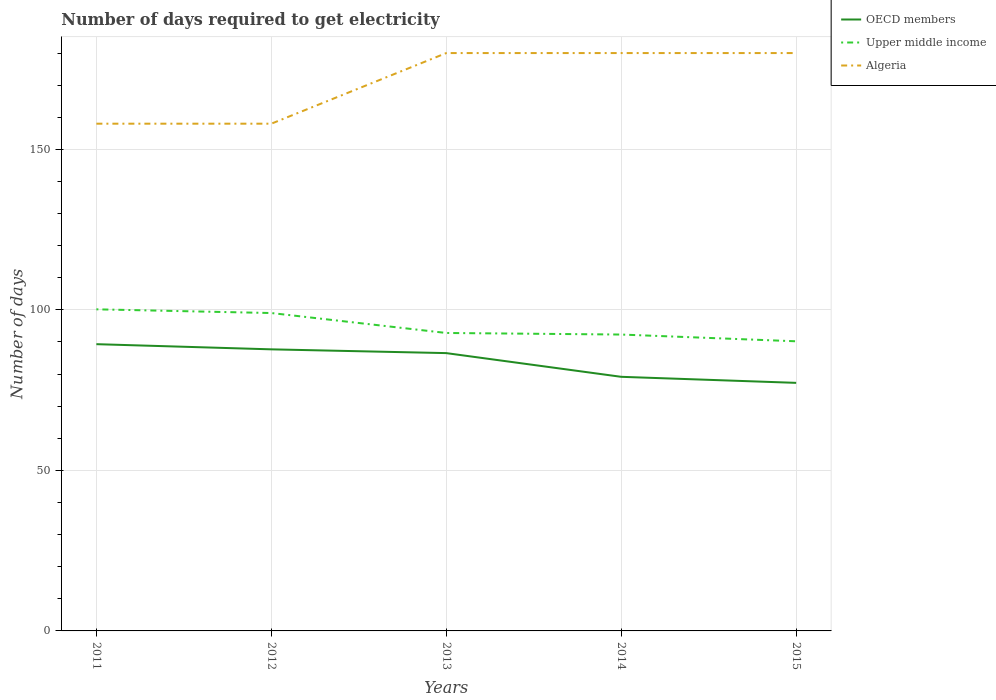How many different coloured lines are there?
Your answer should be compact. 3. Does the line corresponding to Upper middle income intersect with the line corresponding to OECD members?
Give a very brief answer. No. Is the number of lines equal to the number of legend labels?
Give a very brief answer. Yes. Across all years, what is the maximum number of days required to get electricity in in Algeria?
Your answer should be compact. 158. What is the total number of days required to get electricity in in OECD members in the graph?
Offer a terse response. 7.38. What is the difference between the highest and the second highest number of days required to get electricity in in OECD members?
Provide a succinct answer. 12.05. How many lines are there?
Your answer should be compact. 3. Where does the legend appear in the graph?
Provide a succinct answer. Top right. How many legend labels are there?
Your answer should be very brief. 3. What is the title of the graph?
Keep it short and to the point. Number of days required to get electricity. Does "Sub-Saharan Africa (developing only)" appear as one of the legend labels in the graph?
Keep it short and to the point. No. What is the label or title of the Y-axis?
Ensure brevity in your answer.  Number of days. What is the Number of days in OECD members in 2011?
Keep it short and to the point. 89.32. What is the Number of days in Upper middle income in 2011?
Your answer should be very brief. 100.18. What is the Number of days in Algeria in 2011?
Your answer should be very brief. 158. What is the Number of days of OECD members in 2012?
Your answer should be very brief. 87.71. What is the Number of days in Upper middle income in 2012?
Your answer should be very brief. 99.02. What is the Number of days of Algeria in 2012?
Give a very brief answer. 158. What is the Number of days of OECD members in 2013?
Ensure brevity in your answer.  86.54. What is the Number of days of Upper middle income in 2013?
Give a very brief answer. 92.81. What is the Number of days of Algeria in 2013?
Provide a succinct answer. 180. What is the Number of days of OECD members in 2014?
Provide a succinct answer. 79.15. What is the Number of days in Upper middle income in 2014?
Make the answer very short. 92.32. What is the Number of days in Algeria in 2014?
Make the answer very short. 180. What is the Number of days of OECD members in 2015?
Offer a terse response. 77.27. What is the Number of days of Upper middle income in 2015?
Your answer should be compact. 90.22. What is the Number of days in Algeria in 2015?
Make the answer very short. 180. Across all years, what is the maximum Number of days of OECD members?
Your response must be concise. 89.32. Across all years, what is the maximum Number of days in Upper middle income?
Ensure brevity in your answer.  100.18. Across all years, what is the maximum Number of days in Algeria?
Give a very brief answer. 180. Across all years, what is the minimum Number of days in OECD members?
Provide a succinct answer. 77.27. Across all years, what is the minimum Number of days in Upper middle income?
Your answer should be compact. 90.22. Across all years, what is the minimum Number of days in Algeria?
Your answer should be very brief. 158. What is the total Number of days in OECD members in the graph?
Offer a terse response. 419.99. What is the total Number of days of Upper middle income in the graph?
Offer a very short reply. 474.55. What is the total Number of days in Algeria in the graph?
Provide a short and direct response. 856. What is the difference between the Number of days of OECD members in 2011 and that in 2012?
Ensure brevity in your answer.  1.61. What is the difference between the Number of days of Upper middle income in 2011 and that in 2012?
Your answer should be compact. 1.16. What is the difference between the Number of days of Algeria in 2011 and that in 2012?
Give a very brief answer. 0. What is the difference between the Number of days in OECD members in 2011 and that in 2013?
Make the answer very short. 2.79. What is the difference between the Number of days of Upper middle income in 2011 and that in 2013?
Your answer should be compact. 7.37. What is the difference between the Number of days of Algeria in 2011 and that in 2013?
Provide a short and direct response. -22. What is the difference between the Number of days in OECD members in 2011 and that in 2014?
Provide a short and direct response. 10.17. What is the difference between the Number of days in Upper middle income in 2011 and that in 2014?
Offer a very short reply. 7.86. What is the difference between the Number of days in Algeria in 2011 and that in 2014?
Ensure brevity in your answer.  -22. What is the difference between the Number of days of OECD members in 2011 and that in 2015?
Provide a short and direct response. 12.05. What is the difference between the Number of days of Upper middle income in 2011 and that in 2015?
Your answer should be very brief. 9.96. What is the difference between the Number of days in OECD members in 2012 and that in 2013?
Offer a very short reply. 1.17. What is the difference between the Number of days of Upper middle income in 2012 and that in 2013?
Offer a terse response. 6.21. What is the difference between the Number of days in OECD members in 2012 and that in 2014?
Ensure brevity in your answer.  8.56. What is the difference between the Number of days of Upper middle income in 2012 and that in 2014?
Offer a terse response. 6.7. What is the difference between the Number of days in OECD members in 2012 and that in 2015?
Offer a very short reply. 10.44. What is the difference between the Number of days of Upper middle income in 2012 and that in 2015?
Make the answer very short. 8.8. What is the difference between the Number of days in OECD members in 2013 and that in 2014?
Provide a short and direct response. 7.38. What is the difference between the Number of days in Upper middle income in 2013 and that in 2014?
Keep it short and to the point. 0.49. What is the difference between the Number of days in Algeria in 2013 and that in 2014?
Keep it short and to the point. 0. What is the difference between the Number of days of OECD members in 2013 and that in 2015?
Provide a short and direct response. 9.26. What is the difference between the Number of days in Upper middle income in 2013 and that in 2015?
Ensure brevity in your answer.  2.59. What is the difference between the Number of days of OECD members in 2014 and that in 2015?
Keep it short and to the point. 1.88. What is the difference between the Number of days in Upper middle income in 2014 and that in 2015?
Keep it short and to the point. 2.1. What is the difference between the Number of days in Algeria in 2014 and that in 2015?
Give a very brief answer. 0. What is the difference between the Number of days in OECD members in 2011 and the Number of days in Upper middle income in 2012?
Make the answer very short. -9.7. What is the difference between the Number of days in OECD members in 2011 and the Number of days in Algeria in 2012?
Give a very brief answer. -68.68. What is the difference between the Number of days in Upper middle income in 2011 and the Number of days in Algeria in 2012?
Offer a very short reply. -57.82. What is the difference between the Number of days of OECD members in 2011 and the Number of days of Upper middle income in 2013?
Give a very brief answer. -3.49. What is the difference between the Number of days in OECD members in 2011 and the Number of days in Algeria in 2013?
Your answer should be very brief. -90.68. What is the difference between the Number of days in Upper middle income in 2011 and the Number of days in Algeria in 2013?
Provide a short and direct response. -79.82. What is the difference between the Number of days in OECD members in 2011 and the Number of days in Upper middle income in 2014?
Your response must be concise. -3. What is the difference between the Number of days in OECD members in 2011 and the Number of days in Algeria in 2014?
Provide a short and direct response. -90.68. What is the difference between the Number of days in Upper middle income in 2011 and the Number of days in Algeria in 2014?
Offer a very short reply. -79.82. What is the difference between the Number of days of OECD members in 2011 and the Number of days of Upper middle income in 2015?
Offer a terse response. -0.9. What is the difference between the Number of days of OECD members in 2011 and the Number of days of Algeria in 2015?
Your answer should be compact. -90.68. What is the difference between the Number of days of Upper middle income in 2011 and the Number of days of Algeria in 2015?
Keep it short and to the point. -79.82. What is the difference between the Number of days in OECD members in 2012 and the Number of days in Upper middle income in 2013?
Your answer should be compact. -5.1. What is the difference between the Number of days of OECD members in 2012 and the Number of days of Algeria in 2013?
Make the answer very short. -92.29. What is the difference between the Number of days in Upper middle income in 2012 and the Number of days in Algeria in 2013?
Provide a succinct answer. -80.98. What is the difference between the Number of days in OECD members in 2012 and the Number of days in Upper middle income in 2014?
Provide a short and direct response. -4.61. What is the difference between the Number of days of OECD members in 2012 and the Number of days of Algeria in 2014?
Give a very brief answer. -92.29. What is the difference between the Number of days in Upper middle income in 2012 and the Number of days in Algeria in 2014?
Your answer should be compact. -80.98. What is the difference between the Number of days of OECD members in 2012 and the Number of days of Upper middle income in 2015?
Ensure brevity in your answer.  -2.51. What is the difference between the Number of days in OECD members in 2012 and the Number of days in Algeria in 2015?
Keep it short and to the point. -92.29. What is the difference between the Number of days in Upper middle income in 2012 and the Number of days in Algeria in 2015?
Keep it short and to the point. -80.98. What is the difference between the Number of days in OECD members in 2013 and the Number of days in Upper middle income in 2014?
Give a very brief answer. -5.79. What is the difference between the Number of days of OECD members in 2013 and the Number of days of Algeria in 2014?
Make the answer very short. -93.46. What is the difference between the Number of days of Upper middle income in 2013 and the Number of days of Algeria in 2014?
Provide a short and direct response. -87.19. What is the difference between the Number of days in OECD members in 2013 and the Number of days in Upper middle income in 2015?
Your response must be concise. -3.68. What is the difference between the Number of days of OECD members in 2013 and the Number of days of Algeria in 2015?
Ensure brevity in your answer.  -93.46. What is the difference between the Number of days in Upper middle income in 2013 and the Number of days in Algeria in 2015?
Your answer should be compact. -87.19. What is the difference between the Number of days of OECD members in 2014 and the Number of days of Upper middle income in 2015?
Provide a short and direct response. -11.07. What is the difference between the Number of days in OECD members in 2014 and the Number of days in Algeria in 2015?
Your answer should be very brief. -100.85. What is the difference between the Number of days of Upper middle income in 2014 and the Number of days of Algeria in 2015?
Your answer should be compact. -87.68. What is the average Number of days of OECD members per year?
Your answer should be compact. 84. What is the average Number of days in Upper middle income per year?
Your answer should be compact. 94.91. What is the average Number of days of Algeria per year?
Give a very brief answer. 171.2. In the year 2011, what is the difference between the Number of days in OECD members and Number of days in Upper middle income?
Provide a succinct answer. -10.86. In the year 2011, what is the difference between the Number of days in OECD members and Number of days in Algeria?
Provide a succinct answer. -68.68. In the year 2011, what is the difference between the Number of days in Upper middle income and Number of days in Algeria?
Make the answer very short. -57.82. In the year 2012, what is the difference between the Number of days of OECD members and Number of days of Upper middle income?
Keep it short and to the point. -11.31. In the year 2012, what is the difference between the Number of days of OECD members and Number of days of Algeria?
Give a very brief answer. -70.29. In the year 2012, what is the difference between the Number of days of Upper middle income and Number of days of Algeria?
Give a very brief answer. -58.98. In the year 2013, what is the difference between the Number of days of OECD members and Number of days of Upper middle income?
Make the answer very short. -6.27. In the year 2013, what is the difference between the Number of days of OECD members and Number of days of Algeria?
Your answer should be very brief. -93.46. In the year 2013, what is the difference between the Number of days of Upper middle income and Number of days of Algeria?
Provide a short and direct response. -87.19. In the year 2014, what is the difference between the Number of days of OECD members and Number of days of Upper middle income?
Offer a very short reply. -13.17. In the year 2014, what is the difference between the Number of days of OECD members and Number of days of Algeria?
Make the answer very short. -100.85. In the year 2014, what is the difference between the Number of days in Upper middle income and Number of days in Algeria?
Provide a succinct answer. -87.68. In the year 2015, what is the difference between the Number of days in OECD members and Number of days in Upper middle income?
Provide a short and direct response. -12.95. In the year 2015, what is the difference between the Number of days of OECD members and Number of days of Algeria?
Offer a terse response. -102.73. In the year 2015, what is the difference between the Number of days in Upper middle income and Number of days in Algeria?
Your answer should be very brief. -89.78. What is the ratio of the Number of days of OECD members in 2011 to that in 2012?
Provide a succinct answer. 1.02. What is the ratio of the Number of days in Upper middle income in 2011 to that in 2012?
Your answer should be compact. 1.01. What is the ratio of the Number of days in Algeria in 2011 to that in 2012?
Offer a terse response. 1. What is the ratio of the Number of days of OECD members in 2011 to that in 2013?
Provide a short and direct response. 1.03. What is the ratio of the Number of days in Upper middle income in 2011 to that in 2013?
Make the answer very short. 1.08. What is the ratio of the Number of days of Algeria in 2011 to that in 2013?
Keep it short and to the point. 0.88. What is the ratio of the Number of days in OECD members in 2011 to that in 2014?
Provide a succinct answer. 1.13. What is the ratio of the Number of days in Upper middle income in 2011 to that in 2014?
Your answer should be very brief. 1.09. What is the ratio of the Number of days of Algeria in 2011 to that in 2014?
Keep it short and to the point. 0.88. What is the ratio of the Number of days of OECD members in 2011 to that in 2015?
Provide a succinct answer. 1.16. What is the ratio of the Number of days of Upper middle income in 2011 to that in 2015?
Your answer should be compact. 1.11. What is the ratio of the Number of days of Algeria in 2011 to that in 2015?
Make the answer very short. 0.88. What is the ratio of the Number of days in OECD members in 2012 to that in 2013?
Your answer should be compact. 1.01. What is the ratio of the Number of days in Upper middle income in 2012 to that in 2013?
Your answer should be very brief. 1.07. What is the ratio of the Number of days in Algeria in 2012 to that in 2013?
Ensure brevity in your answer.  0.88. What is the ratio of the Number of days of OECD members in 2012 to that in 2014?
Keep it short and to the point. 1.11. What is the ratio of the Number of days of Upper middle income in 2012 to that in 2014?
Your answer should be very brief. 1.07. What is the ratio of the Number of days in Algeria in 2012 to that in 2014?
Your answer should be very brief. 0.88. What is the ratio of the Number of days of OECD members in 2012 to that in 2015?
Make the answer very short. 1.14. What is the ratio of the Number of days in Upper middle income in 2012 to that in 2015?
Offer a terse response. 1.1. What is the ratio of the Number of days in Algeria in 2012 to that in 2015?
Provide a short and direct response. 0.88. What is the ratio of the Number of days of OECD members in 2013 to that in 2014?
Make the answer very short. 1.09. What is the ratio of the Number of days of OECD members in 2013 to that in 2015?
Provide a succinct answer. 1.12. What is the ratio of the Number of days of Upper middle income in 2013 to that in 2015?
Offer a very short reply. 1.03. What is the ratio of the Number of days in Algeria in 2013 to that in 2015?
Make the answer very short. 1. What is the ratio of the Number of days in OECD members in 2014 to that in 2015?
Make the answer very short. 1.02. What is the ratio of the Number of days in Upper middle income in 2014 to that in 2015?
Ensure brevity in your answer.  1.02. What is the ratio of the Number of days of Algeria in 2014 to that in 2015?
Ensure brevity in your answer.  1. What is the difference between the highest and the second highest Number of days in OECD members?
Ensure brevity in your answer.  1.61. What is the difference between the highest and the second highest Number of days in Upper middle income?
Offer a very short reply. 1.16. What is the difference between the highest and the lowest Number of days of OECD members?
Offer a terse response. 12.05. What is the difference between the highest and the lowest Number of days of Upper middle income?
Offer a very short reply. 9.96. What is the difference between the highest and the lowest Number of days of Algeria?
Your answer should be compact. 22. 